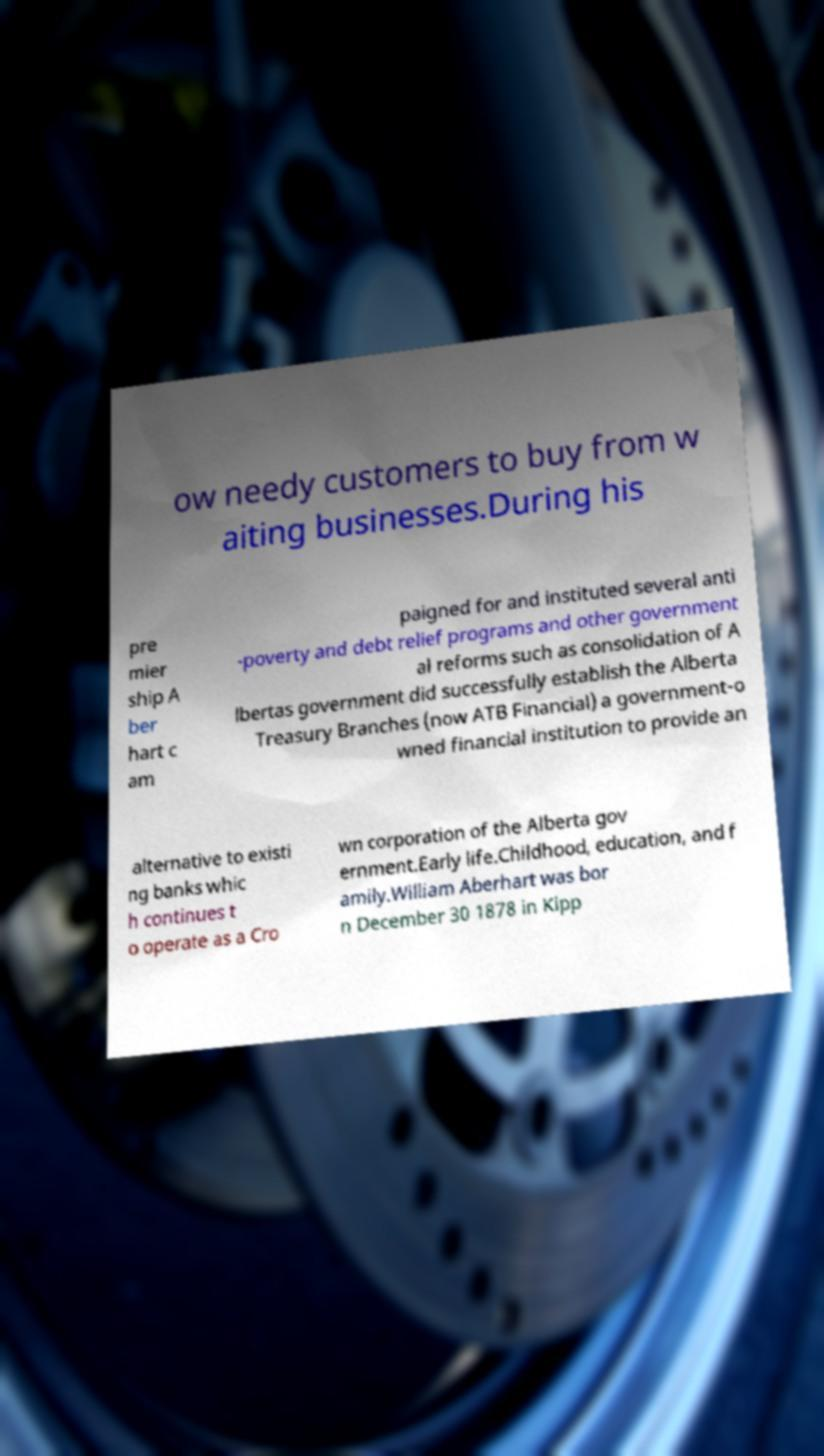Can you read and provide the text displayed in the image?This photo seems to have some interesting text. Can you extract and type it out for me? ow needy customers to buy from w aiting businesses.During his pre mier ship A ber hart c am paigned for and instituted several anti -poverty and debt relief programs and other government al reforms such as consolidation of A lbertas government did successfully establish the Alberta Treasury Branches (now ATB Financial) a government-o wned financial institution to provide an alternative to existi ng banks whic h continues t o operate as a Cro wn corporation of the Alberta gov ernment.Early life.Childhood, education, and f amily.William Aberhart was bor n December 30 1878 in Kipp 